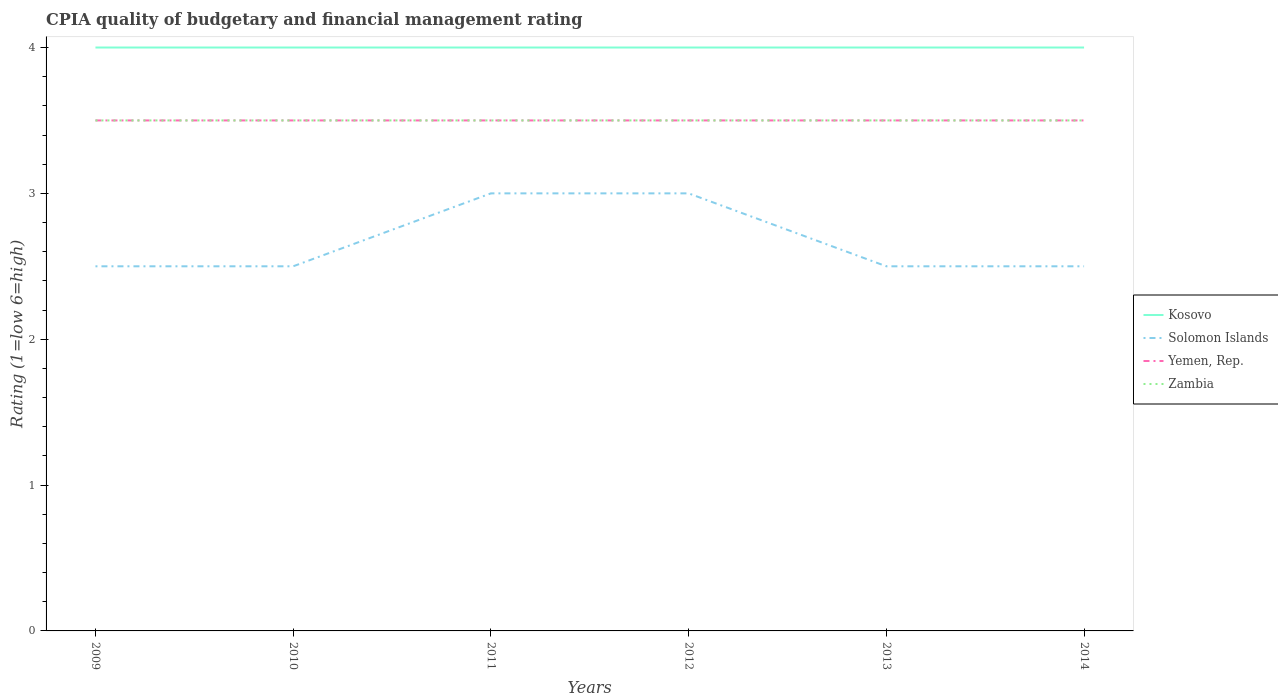Is the number of lines equal to the number of legend labels?
Offer a very short reply. Yes. In which year was the CPIA rating in Zambia maximum?
Your response must be concise. 2009. How many lines are there?
Your answer should be compact. 4. How many years are there in the graph?
Offer a very short reply. 6. Are the values on the major ticks of Y-axis written in scientific E-notation?
Keep it short and to the point. No. How many legend labels are there?
Your answer should be compact. 4. What is the title of the graph?
Your answer should be very brief. CPIA quality of budgetary and financial management rating. Does "Iraq" appear as one of the legend labels in the graph?
Keep it short and to the point. No. What is the label or title of the X-axis?
Keep it short and to the point. Years. What is the Rating (1=low 6=high) of Solomon Islands in 2009?
Provide a succinct answer. 2.5. What is the Rating (1=low 6=high) of Kosovo in 2010?
Provide a short and direct response. 4. What is the Rating (1=low 6=high) in Solomon Islands in 2010?
Offer a terse response. 2.5. What is the Rating (1=low 6=high) of Yemen, Rep. in 2010?
Your answer should be compact. 3.5. What is the Rating (1=low 6=high) in Zambia in 2010?
Provide a short and direct response. 3.5. What is the Rating (1=low 6=high) of Kosovo in 2011?
Your response must be concise. 4. What is the Rating (1=low 6=high) of Zambia in 2011?
Your answer should be compact. 3.5. What is the Rating (1=low 6=high) in Kosovo in 2012?
Provide a succinct answer. 4. What is the Rating (1=low 6=high) in Kosovo in 2013?
Keep it short and to the point. 4. What is the Rating (1=low 6=high) in Solomon Islands in 2013?
Make the answer very short. 2.5. What is the Rating (1=low 6=high) of Zambia in 2013?
Provide a short and direct response. 3.5. What is the Rating (1=low 6=high) in Kosovo in 2014?
Provide a succinct answer. 4. What is the Rating (1=low 6=high) of Solomon Islands in 2014?
Ensure brevity in your answer.  2.5. What is the Rating (1=low 6=high) in Yemen, Rep. in 2014?
Your response must be concise. 3.5. What is the Rating (1=low 6=high) in Zambia in 2014?
Provide a succinct answer. 3.5. Across all years, what is the maximum Rating (1=low 6=high) in Yemen, Rep.?
Your response must be concise. 3.5. Across all years, what is the maximum Rating (1=low 6=high) of Zambia?
Keep it short and to the point. 3.5. Across all years, what is the minimum Rating (1=low 6=high) of Zambia?
Your answer should be very brief. 3.5. What is the total Rating (1=low 6=high) of Kosovo in the graph?
Make the answer very short. 24. What is the total Rating (1=low 6=high) of Solomon Islands in the graph?
Keep it short and to the point. 16. What is the total Rating (1=low 6=high) of Yemen, Rep. in the graph?
Offer a very short reply. 21. What is the total Rating (1=low 6=high) of Zambia in the graph?
Your response must be concise. 21. What is the difference between the Rating (1=low 6=high) in Kosovo in 2009 and that in 2010?
Your answer should be very brief. 0. What is the difference between the Rating (1=low 6=high) of Yemen, Rep. in 2009 and that in 2010?
Ensure brevity in your answer.  0. What is the difference between the Rating (1=low 6=high) in Solomon Islands in 2009 and that in 2011?
Offer a very short reply. -0.5. What is the difference between the Rating (1=low 6=high) in Kosovo in 2009 and that in 2012?
Provide a succinct answer. 0. What is the difference between the Rating (1=low 6=high) in Solomon Islands in 2009 and that in 2012?
Offer a terse response. -0.5. What is the difference between the Rating (1=low 6=high) in Zambia in 2009 and that in 2012?
Your answer should be compact. 0. What is the difference between the Rating (1=low 6=high) of Yemen, Rep. in 2009 and that in 2013?
Provide a succinct answer. 0. What is the difference between the Rating (1=low 6=high) in Zambia in 2009 and that in 2013?
Give a very brief answer. 0. What is the difference between the Rating (1=low 6=high) in Yemen, Rep. in 2009 and that in 2014?
Your answer should be compact. 0. What is the difference between the Rating (1=low 6=high) of Zambia in 2009 and that in 2014?
Offer a very short reply. 0. What is the difference between the Rating (1=low 6=high) in Kosovo in 2010 and that in 2011?
Your answer should be very brief. 0. What is the difference between the Rating (1=low 6=high) of Solomon Islands in 2010 and that in 2011?
Provide a succinct answer. -0.5. What is the difference between the Rating (1=low 6=high) in Yemen, Rep. in 2010 and that in 2011?
Your answer should be compact. 0. What is the difference between the Rating (1=low 6=high) in Zambia in 2010 and that in 2011?
Your answer should be very brief. 0. What is the difference between the Rating (1=low 6=high) in Kosovo in 2010 and that in 2012?
Ensure brevity in your answer.  0. What is the difference between the Rating (1=low 6=high) of Yemen, Rep. in 2010 and that in 2012?
Make the answer very short. 0. What is the difference between the Rating (1=low 6=high) of Kosovo in 2010 and that in 2013?
Make the answer very short. 0. What is the difference between the Rating (1=low 6=high) of Solomon Islands in 2010 and that in 2013?
Ensure brevity in your answer.  0. What is the difference between the Rating (1=low 6=high) in Kosovo in 2010 and that in 2014?
Your answer should be very brief. 0. What is the difference between the Rating (1=low 6=high) of Zambia in 2010 and that in 2014?
Your answer should be very brief. 0. What is the difference between the Rating (1=low 6=high) in Kosovo in 2011 and that in 2012?
Provide a short and direct response. 0. What is the difference between the Rating (1=low 6=high) in Yemen, Rep. in 2011 and that in 2012?
Offer a terse response. 0. What is the difference between the Rating (1=low 6=high) in Zambia in 2011 and that in 2012?
Offer a terse response. 0. What is the difference between the Rating (1=low 6=high) of Kosovo in 2011 and that in 2013?
Offer a terse response. 0. What is the difference between the Rating (1=low 6=high) of Zambia in 2011 and that in 2013?
Your response must be concise. 0. What is the difference between the Rating (1=low 6=high) of Kosovo in 2011 and that in 2014?
Offer a terse response. 0. What is the difference between the Rating (1=low 6=high) of Solomon Islands in 2011 and that in 2014?
Offer a terse response. 0.5. What is the difference between the Rating (1=low 6=high) in Yemen, Rep. in 2011 and that in 2014?
Make the answer very short. 0. What is the difference between the Rating (1=low 6=high) in Zambia in 2011 and that in 2014?
Your answer should be very brief. 0. What is the difference between the Rating (1=low 6=high) of Kosovo in 2012 and that in 2013?
Your answer should be compact. 0. What is the difference between the Rating (1=low 6=high) of Yemen, Rep. in 2012 and that in 2013?
Provide a succinct answer. 0. What is the difference between the Rating (1=low 6=high) in Zambia in 2012 and that in 2013?
Make the answer very short. 0. What is the difference between the Rating (1=low 6=high) of Yemen, Rep. in 2012 and that in 2014?
Offer a terse response. 0. What is the difference between the Rating (1=low 6=high) in Solomon Islands in 2013 and that in 2014?
Provide a short and direct response. 0. What is the difference between the Rating (1=low 6=high) of Yemen, Rep. in 2013 and that in 2014?
Your response must be concise. 0. What is the difference between the Rating (1=low 6=high) in Zambia in 2013 and that in 2014?
Offer a terse response. 0. What is the difference between the Rating (1=low 6=high) of Kosovo in 2009 and the Rating (1=low 6=high) of Yemen, Rep. in 2010?
Your answer should be very brief. 0.5. What is the difference between the Rating (1=low 6=high) of Solomon Islands in 2009 and the Rating (1=low 6=high) of Yemen, Rep. in 2010?
Provide a succinct answer. -1. What is the difference between the Rating (1=low 6=high) of Solomon Islands in 2009 and the Rating (1=low 6=high) of Zambia in 2010?
Provide a succinct answer. -1. What is the difference between the Rating (1=low 6=high) in Yemen, Rep. in 2009 and the Rating (1=low 6=high) in Zambia in 2010?
Make the answer very short. 0. What is the difference between the Rating (1=low 6=high) of Kosovo in 2009 and the Rating (1=low 6=high) of Solomon Islands in 2012?
Keep it short and to the point. 1. What is the difference between the Rating (1=low 6=high) in Kosovo in 2009 and the Rating (1=low 6=high) in Zambia in 2012?
Offer a very short reply. 0.5. What is the difference between the Rating (1=low 6=high) in Solomon Islands in 2009 and the Rating (1=low 6=high) in Zambia in 2012?
Your answer should be compact. -1. What is the difference between the Rating (1=low 6=high) in Yemen, Rep. in 2009 and the Rating (1=low 6=high) in Zambia in 2012?
Your answer should be very brief. 0. What is the difference between the Rating (1=low 6=high) in Kosovo in 2009 and the Rating (1=low 6=high) in Solomon Islands in 2013?
Offer a very short reply. 1.5. What is the difference between the Rating (1=low 6=high) in Kosovo in 2009 and the Rating (1=low 6=high) in Yemen, Rep. in 2013?
Ensure brevity in your answer.  0.5. What is the difference between the Rating (1=low 6=high) of Kosovo in 2009 and the Rating (1=low 6=high) of Zambia in 2013?
Provide a short and direct response. 0.5. What is the difference between the Rating (1=low 6=high) of Solomon Islands in 2009 and the Rating (1=low 6=high) of Yemen, Rep. in 2013?
Provide a short and direct response. -1. What is the difference between the Rating (1=low 6=high) in Solomon Islands in 2009 and the Rating (1=low 6=high) in Zambia in 2013?
Your answer should be compact. -1. What is the difference between the Rating (1=low 6=high) in Kosovo in 2009 and the Rating (1=low 6=high) in Solomon Islands in 2014?
Give a very brief answer. 1.5. What is the difference between the Rating (1=low 6=high) of Kosovo in 2009 and the Rating (1=low 6=high) of Yemen, Rep. in 2014?
Make the answer very short. 0.5. What is the difference between the Rating (1=low 6=high) of Solomon Islands in 2009 and the Rating (1=low 6=high) of Zambia in 2014?
Ensure brevity in your answer.  -1. What is the difference between the Rating (1=low 6=high) of Kosovo in 2010 and the Rating (1=low 6=high) of Yemen, Rep. in 2011?
Your answer should be very brief. 0.5. What is the difference between the Rating (1=low 6=high) of Solomon Islands in 2010 and the Rating (1=low 6=high) of Zambia in 2012?
Make the answer very short. -1. What is the difference between the Rating (1=low 6=high) of Kosovo in 2010 and the Rating (1=low 6=high) of Solomon Islands in 2013?
Your response must be concise. 1.5. What is the difference between the Rating (1=low 6=high) in Kosovo in 2010 and the Rating (1=low 6=high) in Yemen, Rep. in 2013?
Give a very brief answer. 0.5. What is the difference between the Rating (1=low 6=high) of Kosovo in 2010 and the Rating (1=low 6=high) of Zambia in 2013?
Make the answer very short. 0.5. What is the difference between the Rating (1=low 6=high) in Kosovo in 2010 and the Rating (1=low 6=high) in Solomon Islands in 2014?
Offer a very short reply. 1.5. What is the difference between the Rating (1=low 6=high) in Kosovo in 2010 and the Rating (1=low 6=high) in Yemen, Rep. in 2014?
Offer a very short reply. 0.5. What is the difference between the Rating (1=low 6=high) of Solomon Islands in 2010 and the Rating (1=low 6=high) of Yemen, Rep. in 2014?
Provide a short and direct response. -1. What is the difference between the Rating (1=low 6=high) of Yemen, Rep. in 2010 and the Rating (1=low 6=high) of Zambia in 2014?
Keep it short and to the point. 0. What is the difference between the Rating (1=low 6=high) in Kosovo in 2011 and the Rating (1=low 6=high) in Solomon Islands in 2012?
Keep it short and to the point. 1. What is the difference between the Rating (1=low 6=high) of Kosovo in 2011 and the Rating (1=low 6=high) of Yemen, Rep. in 2012?
Make the answer very short. 0.5. What is the difference between the Rating (1=low 6=high) in Solomon Islands in 2011 and the Rating (1=low 6=high) in Zambia in 2012?
Ensure brevity in your answer.  -0.5. What is the difference between the Rating (1=low 6=high) in Yemen, Rep. in 2011 and the Rating (1=low 6=high) in Zambia in 2012?
Give a very brief answer. 0. What is the difference between the Rating (1=low 6=high) of Kosovo in 2011 and the Rating (1=low 6=high) of Yemen, Rep. in 2013?
Make the answer very short. 0.5. What is the difference between the Rating (1=low 6=high) of Kosovo in 2011 and the Rating (1=low 6=high) of Zambia in 2013?
Your answer should be compact. 0.5. What is the difference between the Rating (1=low 6=high) of Solomon Islands in 2011 and the Rating (1=low 6=high) of Yemen, Rep. in 2013?
Your response must be concise. -0.5. What is the difference between the Rating (1=low 6=high) of Kosovo in 2011 and the Rating (1=low 6=high) of Zambia in 2014?
Your answer should be compact. 0.5. What is the difference between the Rating (1=low 6=high) in Yemen, Rep. in 2011 and the Rating (1=low 6=high) in Zambia in 2014?
Your answer should be very brief. 0. What is the difference between the Rating (1=low 6=high) of Kosovo in 2012 and the Rating (1=low 6=high) of Zambia in 2013?
Provide a succinct answer. 0.5. What is the difference between the Rating (1=low 6=high) of Solomon Islands in 2012 and the Rating (1=low 6=high) of Yemen, Rep. in 2013?
Offer a terse response. -0.5. What is the difference between the Rating (1=low 6=high) of Yemen, Rep. in 2012 and the Rating (1=low 6=high) of Zambia in 2013?
Make the answer very short. 0. What is the difference between the Rating (1=low 6=high) of Kosovo in 2012 and the Rating (1=low 6=high) of Solomon Islands in 2014?
Offer a terse response. 1.5. What is the difference between the Rating (1=low 6=high) of Kosovo in 2012 and the Rating (1=low 6=high) of Yemen, Rep. in 2014?
Give a very brief answer. 0.5. What is the difference between the Rating (1=low 6=high) in Kosovo in 2012 and the Rating (1=low 6=high) in Zambia in 2014?
Ensure brevity in your answer.  0.5. What is the difference between the Rating (1=low 6=high) of Kosovo in 2013 and the Rating (1=low 6=high) of Yemen, Rep. in 2014?
Your answer should be very brief. 0.5. What is the difference between the Rating (1=low 6=high) in Kosovo in 2013 and the Rating (1=low 6=high) in Zambia in 2014?
Give a very brief answer. 0.5. What is the difference between the Rating (1=low 6=high) of Solomon Islands in 2013 and the Rating (1=low 6=high) of Yemen, Rep. in 2014?
Provide a succinct answer. -1. What is the difference between the Rating (1=low 6=high) in Yemen, Rep. in 2013 and the Rating (1=low 6=high) in Zambia in 2014?
Keep it short and to the point. 0. What is the average Rating (1=low 6=high) of Kosovo per year?
Keep it short and to the point. 4. What is the average Rating (1=low 6=high) of Solomon Islands per year?
Give a very brief answer. 2.67. What is the average Rating (1=low 6=high) of Yemen, Rep. per year?
Keep it short and to the point. 3.5. In the year 2009, what is the difference between the Rating (1=low 6=high) in Kosovo and Rating (1=low 6=high) in Solomon Islands?
Your response must be concise. 1.5. In the year 2009, what is the difference between the Rating (1=low 6=high) in Kosovo and Rating (1=low 6=high) in Yemen, Rep.?
Your answer should be very brief. 0.5. In the year 2009, what is the difference between the Rating (1=low 6=high) of Kosovo and Rating (1=low 6=high) of Zambia?
Make the answer very short. 0.5. In the year 2010, what is the difference between the Rating (1=low 6=high) in Kosovo and Rating (1=low 6=high) in Solomon Islands?
Keep it short and to the point. 1.5. In the year 2010, what is the difference between the Rating (1=low 6=high) of Kosovo and Rating (1=low 6=high) of Yemen, Rep.?
Your answer should be compact. 0.5. In the year 2011, what is the difference between the Rating (1=low 6=high) of Solomon Islands and Rating (1=low 6=high) of Yemen, Rep.?
Ensure brevity in your answer.  -0.5. In the year 2011, what is the difference between the Rating (1=low 6=high) of Solomon Islands and Rating (1=low 6=high) of Zambia?
Your response must be concise. -0.5. In the year 2011, what is the difference between the Rating (1=low 6=high) of Yemen, Rep. and Rating (1=low 6=high) of Zambia?
Your answer should be compact. 0. In the year 2012, what is the difference between the Rating (1=low 6=high) in Solomon Islands and Rating (1=low 6=high) in Zambia?
Offer a terse response. -0.5. In the year 2012, what is the difference between the Rating (1=low 6=high) of Yemen, Rep. and Rating (1=low 6=high) of Zambia?
Ensure brevity in your answer.  0. In the year 2013, what is the difference between the Rating (1=low 6=high) in Kosovo and Rating (1=low 6=high) in Zambia?
Your answer should be very brief. 0.5. In the year 2013, what is the difference between the Rating (1=low 6=high) of Solomon Islands and Rating (1=low 6=high) of Yemen, Rep.?
Make the answer very short. -1. In the year 2014, what is the difference between the Rating (1=low 6=high) in Kosovo and Rating (1=low 6=high) in Zambia?
Make the answer very short. 0.5. In the year 2014, what is the difference between the Rating (1=low 6=high) in Solomon Islands and Rating (1=low 6=high) in Yemen, Rep.?
Your answer should be very brief. -1. What is the ratio of the Rating (1=low 6=high) in Kosovo in 2009 to that in 2010?
Your response must be concise. 1. What is the ratio of the Rating (1=low 6=high) of Solomon Islands in 2009 to that in 2010?
Offer a very short reply. 1. What is the ratio of the Rating (1=low 6=high) of Yemen, Rep. in 2009 to that in 2010?
Your response must be concise. 1. What is the ratio of the Rating (1=low 6=high) in Solomon Islands in 2009 to that in 2011?
Provide a succinct answer. 0.83. What is the ratio of the Rating (1=low 6=high) in Yemen, Rep. in 2009 to that in 2011?
Your answer should be very brief. 1. What is the ratio of the Rating (1=low 6=high) in Zambia in 2009 to that in 2011?
Your answer should be compact. 1. What is the ratio of the Rating (1=low 6=high) of Solomon Islands in 2009 to that in 2012?
Provide a short and direct response. 0.83. What is the ratio of the Rating (1=low 6=high) in Yemen, Rep. in 2009 to that in 2012?
Ensure brevity in your answer.  1. What is the ratio of the Rating (1=low 6=high) of Kosovo in 2009 to that in 2013?
Your answer should be very brief. 1. What is the ratio of the Rating (1=low 6=high) in Solomon Islands in 2009 to that in 2013?
Your answer should be compact. 1. What is the ratio of the Rating (1=low 6=high) in Yemen, Rep. in 2009 to that in 2013?
Make the answer very short. 1. What is the ratio of the Rating (1=low 6=high) of Zambia in 2009 to that in 2014?
Your response must be concise. 1. What is the ratio of the Rating (1=low 6=high) of Solomon Islands in 2010 to that in 2011?
Your answer should be very brief. 0.83. What is the ratio of the Rating (1=low 6=high) in Yemen, Rep. in 2010 to that in 2011?
Offer a terse response. 1. What is the ratio of the Rating (1=low 6=high) in Zambia in 2010 to that in 2011?
Provide a succinct answer. 1. What is the ratio of the Rating (1=low 6=high) of Yemen, Rep. in 2010 to that in 2012?
Make the answer very short. 1. What is the ratio of the Rating (1=low 6=high) of Yemen, Rep. in 2010 to that in 2013?
Your answer should be compact. 1. What is the ratio of the Rating (1=low 6=high) of Yemen, Rep. in 2010 to that in 2014?
Keep it short and to the point. 1. What is the ratio of the Rating (1=low 6=high) of Yemen, Rep. in 2011 to that in 2012?
Give a very brief answer. 1. What is the ratio of the Rating (1=low 6=high) of Zambia in 2011 to that in 2012?
Your answer should be very brief. 1. What is the ratio of the Rating (1=low 6=high) of Solomon Islands in 2011 to that in 2013?
Give a very brief answer. 1.2. What is the ratio of the Rating (1=low 6=high) of Yemen, Rep. in 2011 to that in 2013?
Make the answer very short. 1. What is the ratio of the Rating (1=low 6=high) in Zambia in 2011 to that in 2013?
Your answer should be compact. 1. What is the ratio of the Rating (1=low 6=high) of Solomon Islands in 2012 to that in 2013?
Offer a very short reply. 1.2. What is the ratio of the Rating (1=low 6=high) of Yemen, Rep. in 2012 to that in 2013?
Make the answer very short. 1. What is the ratio of the Rating (1=low 6=high) of Solomon Islands in 2012 to that in 2014?
Provide a short and direct response. 1.2. What is the ratio of the Rating (1=low 6=high) in Zambia in 2012 to that in 2014?
Give a very brief answer. 1. What is the ratio of the Rating (1=low 6=high) in Solomon Islands in 2013 to that in 2014?
Your answer should be compact. 1. What is the difference between the highest and the second highest Rating (1=low 6=high) of Kosovo?
Keep it short and to the point. 0. What is the difference between the highest and the second highest Rating (1=low 6=high) in Solomon Islands?
Your answer should be very brief. 0. What is the difference between the highest and the second highest Rating (1=low 6=high) in Zambia?
Provide a succinct answer. 0. What is the difference between the highest and the lowest Rating (1=low 6=high) of Yemen, Rep.?
Keep it short and to the point. 0. What is the difference between the highest and the lowest Rating (1=low 6=high) in Zambia?
Give a very brief answer. 0. 